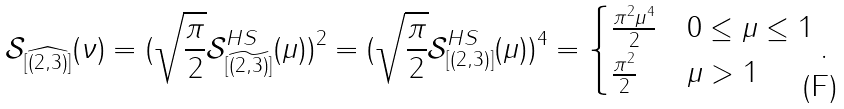Convert formula to latex. <formula><loc_0><loc_0><loc_500><loc_500>\mathcal { S } _ { [ \widehat { ( 2 , 3 ) } ] } ( \nu ) = ( \sqrt { \frac { \pi } { 2 } } \mathcal { S } ^ { H S } _ { [ \widetilde { ( 2 , 3 ) } ] } ( \mu ) ) ^ { 2 } = ( \sqrt { \frac { \pi } { 2 } } \mathcal { S } ^ { H S } _ { [ ( 2 , 3 ) ] } ( \mu ) ) ^ { 4 } = \begin{cases} \frac { \pi ^ { 2 } \mu ^ { 4 } } { 2 } & 0 \leq \mu \leq 1 \\ \frac { \pi ^ { 2 } } { 2 } & \mu > 1 \end{cases} .</formula> 